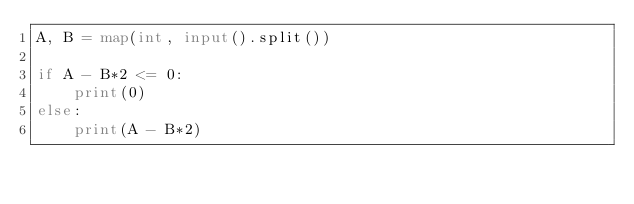<code> <loc_0><loc_0><loc_500><loc_500><_Python_>A, B = map(int, input().split())

if A - B*2 <= 0:
    print(0)
else:
    print(A - B*2)
</code> 